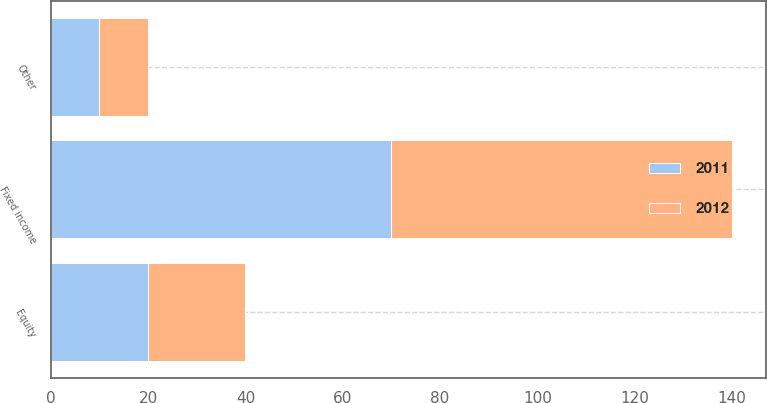Convert chart to OTSL. <chart><loc_0><loc_0><loc_500><loc_500><stacked_bar_chart><ecel><fcel>Fixed income<fcel>Equity<fcel>Other<nl><fcel>2012<fcel>70<fcel>20<fcel>10<nl><fcel>2011<fcel>70<fcel>20<fcel>10<nl></chart> 